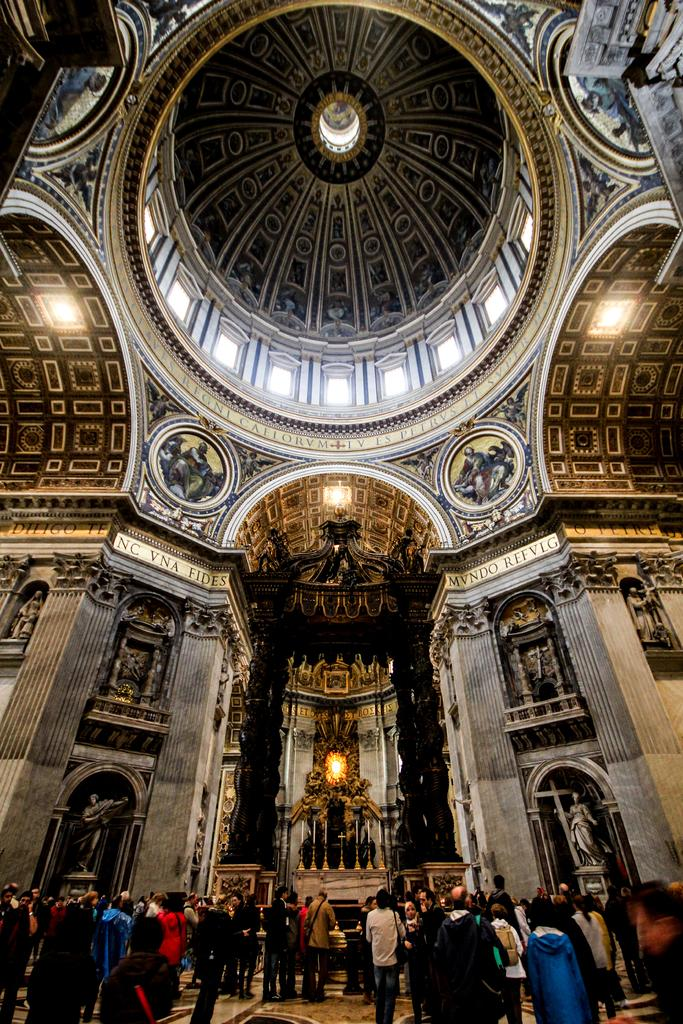What type of location is depicted in the image? The image shows an inside view of a building. Can you describe the people in the image? There is a group of people standing in the image. What can be seen in terms of lighting in the image? There are lights visible in the image. What type of artwork is present in the image? Sculptures are present in the image. What is being used to provide additional light in the image? Candles are visible in the image, and candle stands are present. Are there any other objects or features in the image? Yes, there are other objects in the image. What type of organization is being advertised in the image? There is no organization being advertised in the image; it simply shows an inside view of a building with various objects and people. 